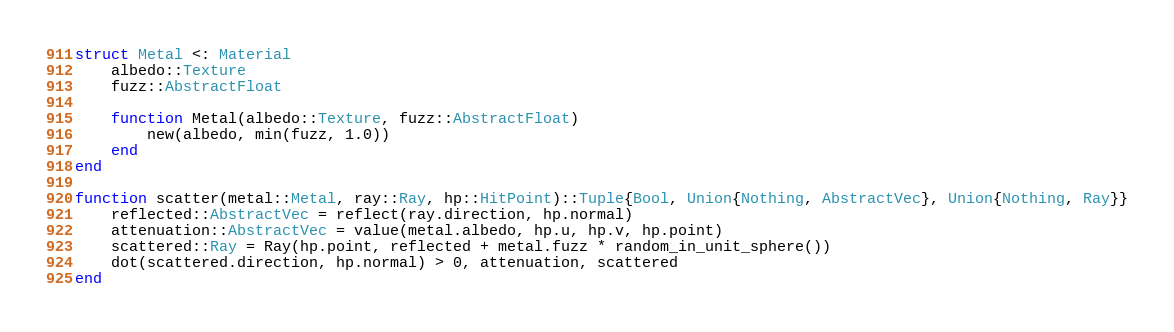<code> <loc_0><loc_0><loc_500><loc_500><_Julia_>struct Metal <: Material
    albedo::Texture
    fuzz::AbstractFloat

    function Metal(albedo::Texture, fuzz::AbstractFloat)
        new(albedo, min(fuzz, 1.0))
    end
end

function scatter(metal::Metal, ray::Ray, hp::HitPoint)::Tuple{Bool, Union{Nothing, AbstractVec}, Union{Nothing, Ray}}
    reflected::AbstractVec = reflect(ray.direction, hp.normal)
    attenuation::AbstractVec = value(metal.albedo, hp.u, hp.v, hp.point)
    scattered::Ray = Ray(hp.point, reflected + metal.fuzz * random_in_unit_sphere())
    dot(scattered.direction, hp.normal) > 0, attenuation, scattered
end

</code> 